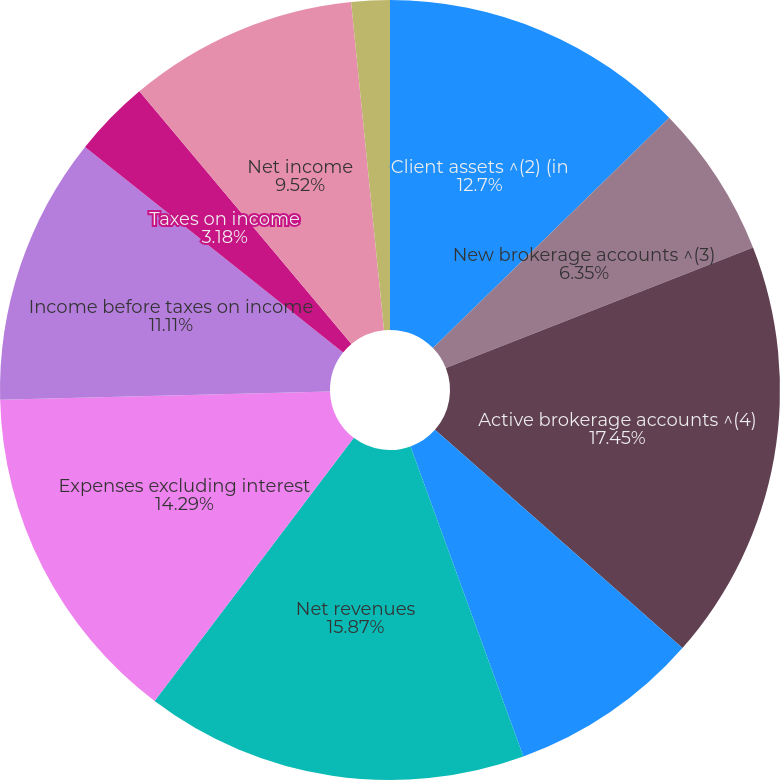Convert chart to OTSL. <chart><loc_0><loc_0><loc_500><loc_500><pie_chart><fcel>Client assets ^(2) (in<fcel>New brokerage accounts ^(3)<fcel>Active brokerage accounts ^(4)<fcel>Assets receiving ongoing<fcel>Net revenues<fcel>Expenses excluding interest<fcel>Income before taxes on income<fcel>Taxes on income<fcel>Net income<fcel>Preferred stock dividends<nl><fcel>12.7%<fcel>6.35%<fcel>17.46%<fcel>7.94%<fcel>15.87%<fcel>14.29%<fcel>11.11%<fcel>3.18%<fcel>9.52%<fcel>1.59%<nl></chart> 